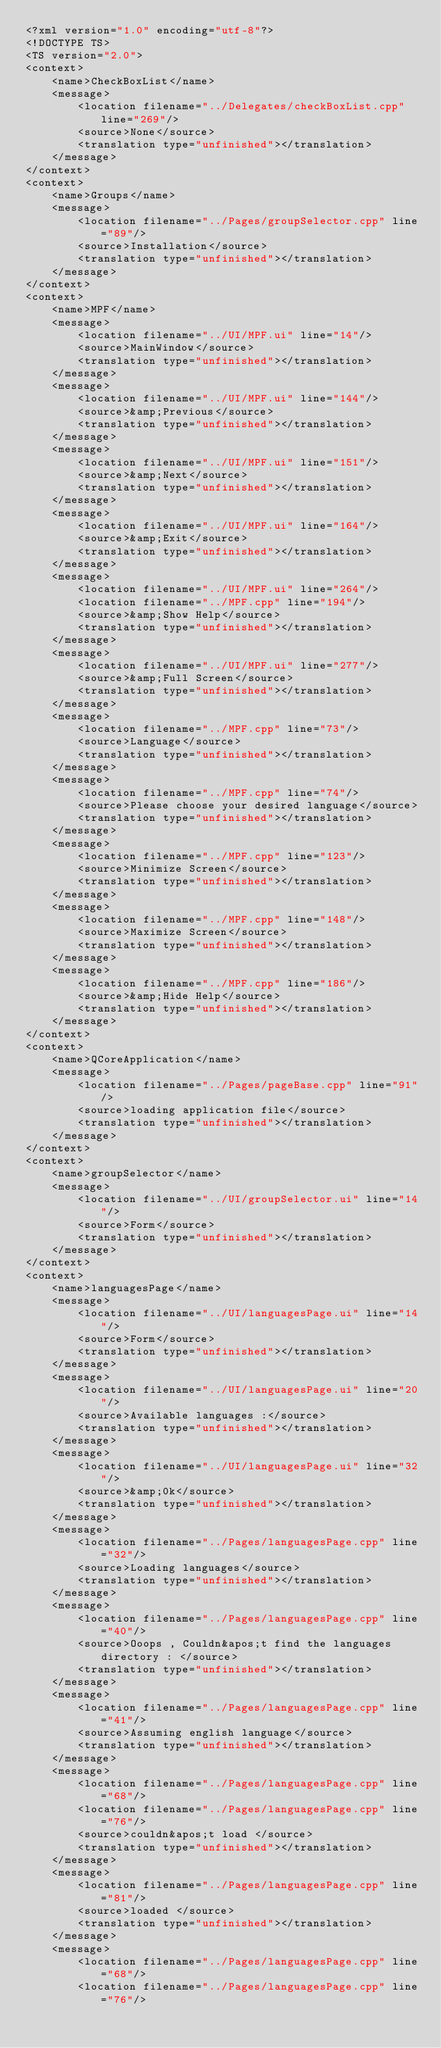<code> <loc_0><loc_0><loc_500><loc_500><_TypeScript_><?xml version="1.0" encoding="utf-8"?>
<!DOCTYPE TS>
<TS version="2.0">
<context>
    <name>CheckBoxList</name>
    <message>
        <location filename="../Delegates/checkBoxList.cpp" line="269"/>
        <source>None</source>
        <translation type="unfinished"></translation>
    </message>
</context>
<context>
    <name>Groups</name>
    <message>
        <location filename="../Pages/groupSelector.cpp" line="89"/>
        <source>Installation</source>
        <translation type="unfinished"></translation>
    </message>
</context>
<context>
    <name>MPF</name>
    <message>
        <location filename="../UI/MPF.ui" line="14"/>
        <source>MainWindow</source>
        <translation type="unfinished"></translation>
    </message>
    <message>
        <location filename="../UI/MPF.ui" line="144"/>
        <source>&amp;Previous</source>
        <translation type="unfinished"></translation>
    </message>
    <message>
        <location filename="../UI/MPF.ui" line="151"/>
        <source>&amp;Next</source>
        <translation type="unfinished"></translation>
    </message>
    <message>
        <location filename="../UI/MPF.ui" line="164"/>
        <source>&amp;Exit</source>
        <translation type="unfinished"></translation>
    </message>
    <message>
        <location filename="../UI/MPF.ui" line="264"/>
        <location filename="../MPF.cpp" line="194"/>
        <source>&amp;Show Help</source>
        <translation type="unfinished"></translation>
    </message>
    <message>
        <location filename="../UI/MPF.ui" line="277"/>
        <source>&amp;Full Screen</source>
        <translation type="unfinished"></translation>
    </message>
    <message>
        <location filename="../MPF.cpp" line="73"/>
        <source>Language</source>
        <translation type="unfinished"></translation>
    </message>
    <message>
        <location filename="../MPF.cpp" line="74"/>
        <source>Please choose your desired language</source>
        <translation type="unfinished"></translation>
    </message>
    <message>
        <location filename="../MPF.cpp" line="123"/>
        <source>Minimize Screen</source>
        <translation type="unfinished"></translation>
    </message>
    <message>
        <location filename="../MPF.cpp" line="148"/>
        <source>Maximize Screen</source>
        <translation type="unfinished"></translation>
    </message>
    <message>
        <location filename="../MPF.cpp" line="186"/>
        <source>&amp;Hide Help</source>
        <translation type="unfinished"></translation>
    </message>
</context>
<context>
    <name>QCoreApplication</name>
    <message>
        <location filename="../Pages/pageBase.cpp" line="91"/>
        <source>loading application file</source>
        <translation type="unfinished"></translation>
    </message>
</context>
<context>
    <name>groupSelector</name>
    <message>
        <location filename="../UI/groupSelector.ui" line="14"/>
        <source>Form</source>
        <translation type="unfinished"></translation>
    </message>
</context>
<context>
    <name>languagesPage</name>
    <message>
        <location filename="../UI/languagesPage.ui" line="14"/>
        <source>Form</source>
        <translation type="unfinished"></translation>
    </message>
    <message>
        <location filename="../UI/languagesPage.ui" line="20"/>
        <source>Available languages :</source>
        <translation type="unfinished"></translation>
    </message>
    <message>
        <location filename="../UI/languagesPage.ui" line="32"/>
        <source>&amp;0k</source>
        <translation type="unfinished"></translation>
    </message>
    <message>
        <location filename="../Pages/languagesPage.cpp" line="32"/>
        <source>Loading languages</source>
        <translation type="unfinished"></translation>
    </message>
    <message>
        <location filename="../Pages/languagesPage.cpp" line="40"/>
        <source>Ooops , Couldn&apos;t find the languages directory : </source>
        <translation type="unfinished"></translation>
    </message>
    <message>
        <location filename="../Pages/languagesPage.cpp" line="41"/>
        <source>Assuming english language</source>
        <translation type="unfinished"></translation>
    </message>
    <message>
        <location filename="../Pages/languagesPage.cpp" line="68"/>
        <location filename="../Pages/languagesPage.cpp" line="76"/>
        <source>couldn&apos;t load </source>
        <translation type="unfinished"></translation>
    </message>
    <message>
        <location filename="../Pages/languagesPage.cpp" line="81"/>
        <source>loaded </source>
        <translation type="unfinished"></translation>
    </message>
    <message>
        <location filename="../Pages/languagesPage.cpp" line="68"/>
        <location filename="../Pages/languagesPage.cpp" line="76"/></code> 